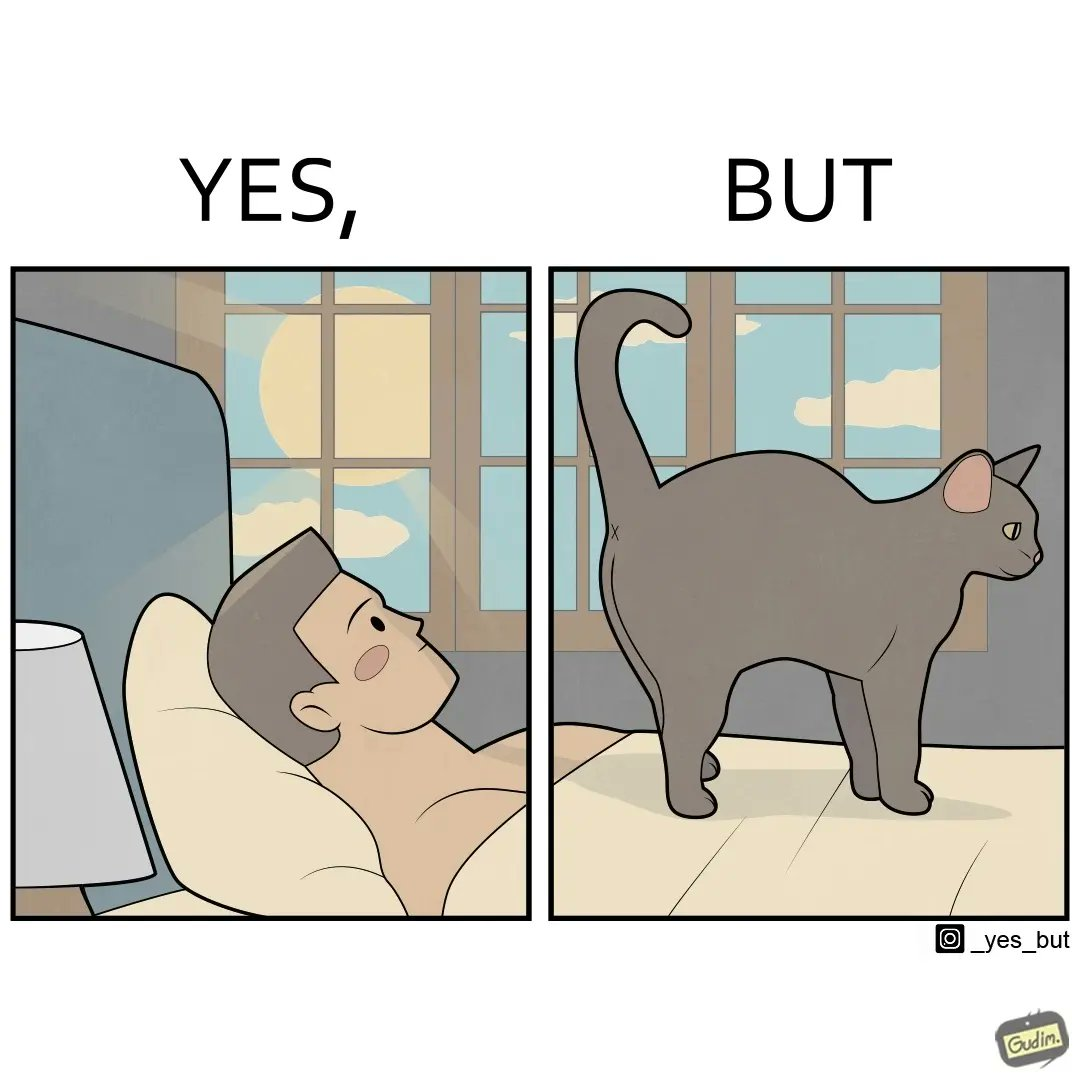Explain why this image is satirical. The image just speaks yes, but in a different way as "yes, butt" like in the early morning the man had to look at the cat's butt because it is standing over the man's body 